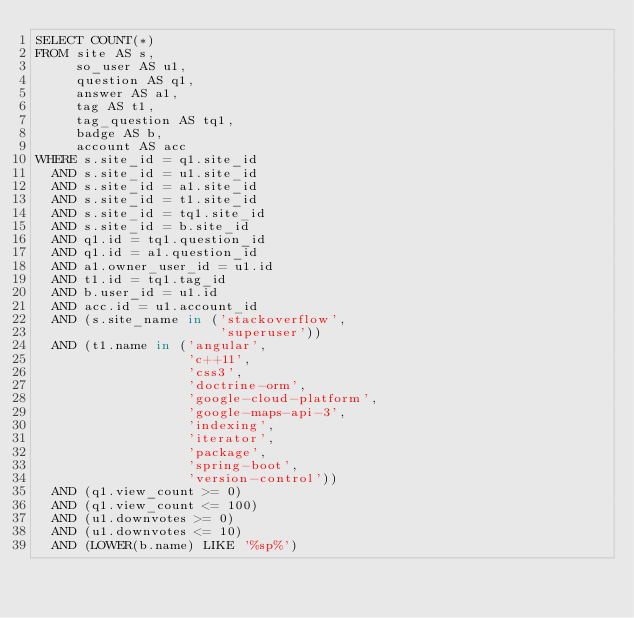<code> <loc_0><loc_0><loc_500><loc_500><_SQL_>SELECT COUNT(*)
FROM site AS s,
     so_user AS u1,
     question AS q1,
     answer AS a1,
     tag AS t1,
     tag_question AS tq1,
     badge AS b,
     account AS acc
WHERE s.site_id = q1.site_id
  AND s.site_id = u1.site_id
  AND s.site_id = a1.site_id
  AND s.site_id = t1.site_id
  AND s.site_id = tq1.site_id
  AND s.site_id = b.site_id
  AND q1.id = tq1.question_id
  AND q1.id = a1.question_id
  AND a1.owner_user_id = u1.id
  AND t1.id = tq1.tag_id
  AND b.user_id = u1.id
  AND acc.id = u1.account_id
  AND (s.site_name in ('stackoverflow',
                       'superuser'))
  AND (t1.name in ('angular',
                   'c++11',
                   'css3',
                   'doctrine-orm',
                   'google-cloud-platform',
                   'google-maps-api-3',
                   'indexing',
                   'iterator',
                   'package',
                   'spring-boot',
                   'version-control'))
  AND (q1.view_count >= 0)
  AND (q1.view_count <= 100)
  AND (u1.downvotes >= 0)
  AND (u1.downvotes <= 10)
  AND (LOWER(b.name) LIKE '%sp%')</code> 